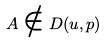Convert formula to latex. <formula><loc_0><loc_0><loc_500><loc_500>A \notin D ( u , p )</formula> 